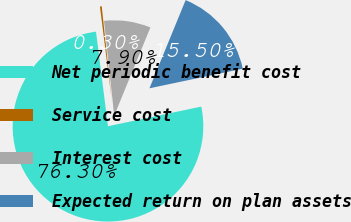Convert chart. <chart><loc_0><loc_0><loc_500><loc_500><pie_chart><fcel>Net periodic benefit cost<fcel>Service cost<fcel>Interest cost<fcel>Expected return on plan assets<nl><fcel>76.29%<fcel>0.3%<fcel>7.9%<fcel>15.5%<nl></chart> 